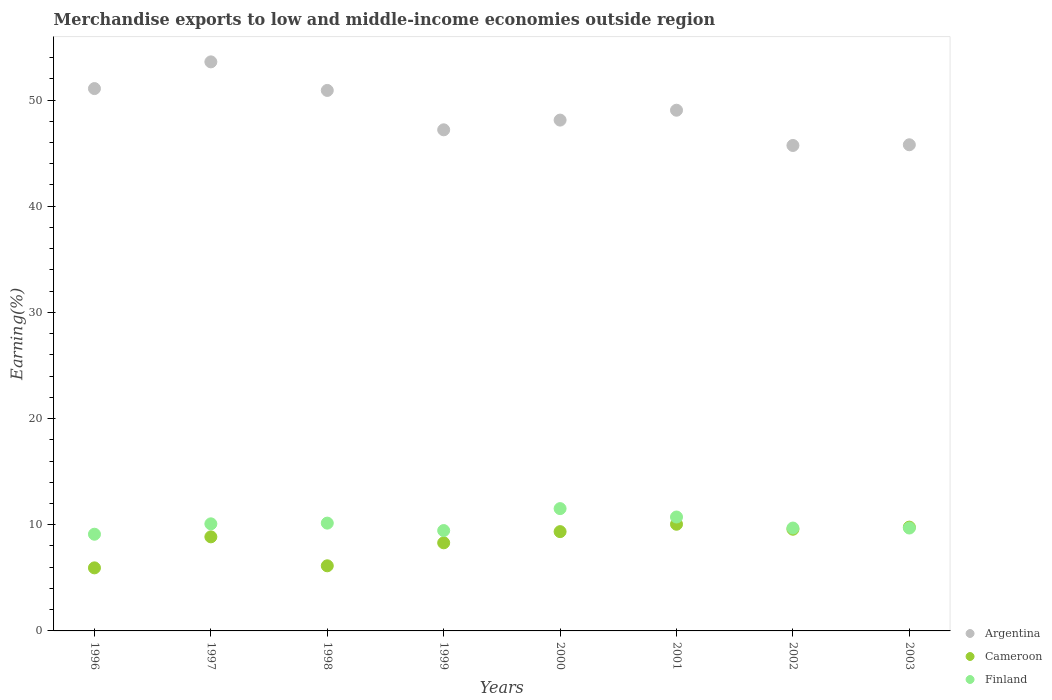How many different coloured dotlines are there?
Offer a terse response. 3. What is the percentage of amount earned from merchandise exports in Finland in 1996?
Your answer should be compact. 9.11. Across all years, what is the maximum percentage of amount earned from merchandise exports in Finland?
Make the answer very short. 11.52. Across all years, what is the minimum percentage of amount earned from merchandise exports in Argentina?
Your response must be concise. 45.72. What is the total percentage of amount earned from merchandise exports in Finland in the graph?
Your answer should be compact. 80.43. What is the difference between the percentage of amount earned from merchandise exports in Cameroon in 2000 and that in 2003?
Your answer should be very brief. -0.43. What is the difference between the percentage of amount earned from merchandise exports in Cameroon in 1997 and the percentage of amount earned from merchandise exports in Argentina in 1999?
Your answer should be very brief. -38.34. What is the average percentage of amount earned from merchandise exports in Finland per year?
Your answer should be very brief. 10.05. In the year 1996, what is the difference between the percentage of amount earned from merchandise exports in Finland and percentage of amount earned from merchandise exports in Cameroon?
Make the answer very short. 3.17. What is the ratio of the percentage of amount earned from merchandise exports in Argentina in 1996 to that in 2003?
Your response must be concise. 1.12. What is the difference between the highest and the second highest percentage of amount earned from merchandise exports in Cameroon?
Your answer should be compact. 0.27. What is the difference between the highest and the lowest percentage of amount earned from merchandise exports in Argentina?
Provide a short and direct response. 7.87. Does the percentage of amount earned from merchandise exports in Cameroon monotonically increase over the years?
Offer a terse response. No. How many years are there in the graph?
Ensure brevity in your answer.  8. Are the values on the major ticks of Y-axis written in scientific E-notation?
Your answer should be very brief. No. Does the graph contain any zero values?
Provide a short and direct response. No. Does the graph contain grids?
Your answer should be compact. No. How are the legend labels stacked?
Ensure brevity in your answer.  Vertical. What is the title of the graph?
Make the answer very short. Merchandise exports to low and middle-income economies outside region. What is the label or title of the X-axis?
Your answer should be very brief. Years. What is the label or title of the Y-axis?
Offer a very short reply. Earning(%). What is the Earning(%) in Argentina in 1996?
Provide a succinct answer. 51.08. What is the Earning(%) in Cameroon in 1996?
Keep it short and to the point. 5.94. What is the Earning(%) of Finland in 1996?
Make the answer very short. 9.11. What is the Earning(%) in Argentina in 1997?
Offer a very short reply. 53.6. What is the Earning(%) in Cameroon in 1997?
Offer a terse response. 8.86. What is the Earning(%) in Finland in 1997?
Offer a terse response. 10.09. What is the Earning(%) in Argentina in 1998?
Your answer should be compact. 50.91. What is the Earning(%) in Cameroon in 1998?
Provide a short and direct response. 6.13. What is the Earning(%) of Finland in 1998?
Provide a short and direct response. 10.15. What is the Earning(%) of Argentina in 1999?
Your answer should be very brief. 47.2. What is the Earning(%) of Cameroon in 1999?
Your response must be concise. 8.3. What is the Earning(%) of Finland in 1999?
Your answer should be very brief. 9.45. What is the Earning(%) in Argentina in 2000?
Offer a terse response. 48.11. What is the Earning(%) of Cameroon in 2000?
Provide a short and direct response. 9.35. What is the Earning(%) of Finland in 2000?
Provide a short and direct response. 11.52. What is the Earning(%) in Argentina in 2001?
Give a very brief answer. 49.04. What is the Earning(%) in Cameroon in 2001?
Provide a short and direct response. 10.05. What is the Earning(%) of Finland in 2001?
Keep it short and to the point. 10.73. What is the Earning(%) of Argentina in 2002?
Keep it short and to the point. 45.72. What is the Earning(%) of Cameroon in 2002?
Your answer should be compact. 9.58. What is the Earning(%) in Finland in 2002?
Give a very brief answer. 9.69. What is the Earning(%) in Argentina in 2003?
Give a very brief answer. 45.79. What is the Earning(%) of Cameroon in 2003?
Keep it short and to the point. 9.78. What is the Earning(%) of Finland in 2003?
Provide a short and direct response. 9.69. Across all years, what is the maximum Earning(%) of Argentina?
Keep it short and to the point. 53.6. Across all years, what is the maximum Earning(%) in Cameroon?
Provide a short and direct response. 10.05. Across all years, what is the maximum Earning(%) of Finland?
Provide a succinct answer. 11.52. Across all years, what is the minimum Earning(%) of Argentina?
Offer a very short reply. 45.72. Across all years, what is the minimum Earning(%) in Cameroon?
Ensure brevity in your answer.  5.94. Across all years, what is the minimum Earning(%) of Finland?
Keep it short and to the point. 9.11. What is the total Earning(%) in Argentina in the graph?
Ensure brevity in your answer.  391.44. What is the total Earning(%) of Cameroon in the graph?
Your response must be concise. 67.98. What is the total Earning(%) of Finland in the graph?
Offer a terse response. 80.43. What is the difference between the Earning(%) of Argentina in 1996 and that in 1997?
Your response must be concise. -2.51. What is the difference between the Earning(%) of Cameroon in 1996 and that in 1997?
Keep it short and to the point. -2.92. What is the difference between the Earning(%) in Finland in 1996 and that in 1997?
Keep it short and to the point. -0.98. What is the difference between the Earning(%) of Argentina in 1996 and that in 1998?
Your answer should be compact. 0.17. What is the difference between the Earning(%) in Cameroon in 1996 and that in 1998?
Offer a terse response. -0.19. What is the difference between the Earning(%) of Finland in 1996 and that in 1998?
Keep it short and to the point. -1.05. What is the difference between the Earning(%) in Argentina in 1996 and that in 1999?
Provide a succinct answer. 3.88. What is the difference between the Earning(%) in Cameroon in 1996 and that in 1999?
Keep it short and to the point. -2.36. What is the difference between the Earning(%) of Finland in 1996 and that in 1999?
Your response must be concise. -0.34. What is the difference between the Earning(%) in Argentina in 1996 and that in 2000?
Your answer should be compact. 2.97. What is the difference between the Earning(%) in Cameroon in 1996 and that in 2000?
Offer a very short reply. -3.41. What is the difference between the Earning(%) in Finland in 1996 and that in 2000?
Offer a terse response. -2.41. What is the difference between the Earning(%) in Argentina in 1996 and that in 2001?
Your answer should be very brief. 2.04. What is the difference between the Earning(%) in Cameroon in 1996 and that in 2001?
Your answer should be very brief. -4.11. What is the difference between the Earning(%) in Finland in 1996 and that in 2001?
Provide a succinct answer. -1.62. What is the difference between the Earning(%) of Argentina in 1996 and that in 2002?
Your answer should be very brief. 5.36. What is the difference between the Earning(%) in Cameroon in 1996 and that in 2002?
Offer a terse response. -3.64. What is the difference between the Earning(%) in Finland in 1996 and that in 2002?
Give a very brief answer. -0.58. What is the difference between the Earning(%) in Argentina in 1996 and that in 2003?
Give a very brief answer. 5.29. What is the difference between the Earning(%) of Cameroon in 1996 and that in 2003?
Offer a very short reply. -3.84. What is the difference between the Earning(%) in Finland in 1996 and that in 2003?
Your answer should be compact. -0.58. What is the difference between the Earning(%) in Argentina in 1997 and that in 1998?
Provide a succinct answer. 2.69. What is the difference between the Earning(%) in Cameroon in 1997 and that in 1998?
Your answer should be very brief. 2.73. What is the difference between the Earning(%) of Finland in 1997 and that in 1998?
Provide a succinct answer. -0.07. What is the difference between the Earning(%) of Argentina in 1997 and that in 1999?
Your answer should be compact. 6.4. What is the difference between the Earning(%) of Cameroon in 1997 and that in 1999?
Keep it short and to the point. 0.56. What is the difference between the Earning(%) in Finland in 1997 and that in 1999?
Provide a short and direct response. 0.63. What is the difference between the Earning(%) in Argentina in 1997 and that in 2000?
Your answer should be compact. 5.48. What is the difference between the Earning(%) of Cameroon in 1997 and that in 2000?
Provide a succinct answer. -0.49. What is the difference between the Earning(%) in Finland in 1997 and that in 2000?
Keep it short and to the point. -1.43. What is the difference between the Earning(%) in Argentina in 1997 and that in 2001?
Give a very brief answer. 4.55. What is the difference between the Earning(%) of Cameroon in 1997 and that in 2001?
Provide a short and direct response. -1.19. What is the difference between the Earning(%) in Finland in 1997 and that in 2001?
Your answer should be compact. -0.64. What is the difference between the Earning(%) in Argentina in 1997 and that in 2002?
Give a very brief answer. 7.87. What is the difference between the Earning(%) of Cameroon in 1997 and that in 2002?
Offer a terse response. -0.72. What is the difference between the Earning(%) of Finland in 1997 and that in 2002?
Provide a short and direct response. 0.4. What is the difference between the Earning(%) in Argentina in 1997 and that in 2003?
Offer a terse response. 7.81. What is the difference between the Earning(%) in Cameroon in 1997 and that in 2003?
Your response must be concise. -0.92. What is the difference between the Earning(%) in Finland in 1997 and that in 2003?
Make the answer very short. 0.39. What is the difference between the Earning(%) in Argentina in 1998 and that in 1999?
Ensure brevity in your answer.  3.71. What is the difference between the Earning(%) in Cameroon in 1998 and that in 1999?
Offer a terse response. -2.16. What is the difference between the Earning(%) in Finland in 1998 and that in 1999?
Ensure brevity in your answer.  0.7. What is the difference between the Earning(%) in Argentina in 1998 and that in 2000?
Provide a succinct answer. 2.79. What is the difference between the Earning(%) in Cameroon in 1998 and that in 2000?
Provide a short and direct response. -3.22. What is the difference between the Earning(%) in Finland in 1998 and that in 2000?
Ensure brevity in your answer.  -1.37. What is the difference between the Earning(%) of Argentina in 1998 and that in 2001?
Your answer should be compact. 1.86. What is the difference between the Earning(%) in Cameroon in 1998 and that in 2001?
Provide a short and direct response. -3.91. What is the difference between the Earning(%) of Finland in 1998 and that in 2001?
Make the answer very short. -0.58. What is the difference between the Earning(%) in Argentina in 1998 and that in 2002?
Offer a very short reply. 5.18. What is the difference between the Earning(%) in Cameroon in 1998 and that in 2002?
Offer a terse response. -3.44. What is the difference between the Earning(%) of Finland in 1998 and that in 2002?
Offer a very short reply. 0.46. What is the difference between the Earning(%) of Argentina in 1998 and that in 2003?
Give a very brief answer. 5.12. What is the difference between the Earning(%) in Cameroon in 1998 and that in 2003?
Offer a terse response. -3.64. What is the difference between the Earning(%) in Finland in 1998 and that in 2003?
Provide a short and direct response. 0.46. What is the difference between the Earning(%) of Argentina in 1999 and that in 2000?
Your response must be concise. -0.91. What is the difference between the Earning(%) in Cameroon in 1999 and that in 2000?
Your response must be concise. -1.05. What is the difference between the Earning(%) of Finland in 1999 and that in 2000?
Keep it short and to the point. -2.07. What is the difference between the Earning(%) in Argentina in 1999 and that in 2001?
Keep it short and to the point. -1.85. What is the difference between the Earning(%) in Cameroon in 1999 and that in 2001?
Give a very brief answer. -1.75. What is the difference between the Earning(%) in Finland in 1999 and that in 2001?
Provide a succinct answer. -1.28. What is the difference between the Earning(%) in Argentina in 1999 and that in 2002?
Make the answer very short. 1.47. What is the difference between the Earning(%) of Cameroon in 1999 and that in 2002?
Provide a succinct answer. -1.28. What is the difference between the Earning(%) in Finland in 1999 and that in 2002?
Provide a short and direct response. -0.24. What is the difference between the Earning(%) in Argentina in 1999 and that in 2003?
Ensure brevity in your answer.  1.41. What is the difference between the Earning(%) in Cameroon in 1999 and that in 2003?
Your answer should be compact. -1.48. What is the difference between the Earning(%) in Finland in 1999 and that in 2003?
Offer a very short reply. -0.24. What is the difference between the Earning(%) in Argentina in 2000 and that in 2001?
Make the answer very short. -0.93. What is the difference between the Earning(%) of Cameroon in 2000 and that in 2001?
Keep it short and to the point. -0.7. What is the difference between the Earning(%) in Finland in 2000 and that in 2001?
Make the answer very short. 0.79. What is the difference between the Earning(%) in Argentina in 2000 and that in 2002?
Offer a terse response. 2.39. What is the difference between the Earning(%) of Cameroon in 2000 and that in 2002?
Provide a succinct answer. -0.23. What is the difference between the Earning(%) of Finland in 2000 and that in 2002?
Ensure brevity in your answer.  1.83. What is the difference between the Earning(%) of Argentina in 2000 and that in 2003?
Your response must be concise. 2.32. What is the difference between the Earning(%) of Cameroon in 2000 and that in 2003?
Make the answer very short. -0.43. What is the difference between the Earning(%) in Finland in 2000 and that in 2003?
Offer a very short reply. 1.83. What is the difference between the Earning(%) in Argentina in 2001 and that in 2002?
Provide a succinct answer. 3.32. What is the difference between the Earning(%) in Cameroon in 2001 and that in 2002?
Offer a terse response. 0.47. What is the difference between the Earning(%) of Finland in 2001 and that in 2002?
Your answer should be compact. 1.04. What is the difference between the Earning(%) of Argentina in 2001 and that in 2003?
Ensure brevity in your answer.  3.25. What is the difference between the Earning(%) of Cameroon in 2001 and that in 2003?
Give a very brief answer. 0.27. What is the difference between the Earning(%) of Finland in 2001 and that in 2003?
Ensure brevity in your answer.  1.04. What is the difference between the Earning(%) of Argentina in 2002 and that in 2003?
Make the answer very short. -0.07. What is the difference between the Earning(%) in Cameroon in 2002 and that in 2003?
Give a very brief answer. -0.2. What is the difference between the Earning(%) in Finland in 2002 and that in 2003?
Make the answer very short. -0. What is the difference between the Earning(%) in Argentina in 1996 and the Earning(%) in Cameroon in 1997?
Keep it short and to the point. 42.22. What is the difference between the Earning(%) of Argentina in 1996 and the Earning(%) of Finland in 1997?
Give a very brief answer. 40.99. What is the difference between the Earning(%) of Cameroon in 1996 and the Earning(%) of Finland in 1997?
Your answer should be very brief. -4.15. What is the difference between the Earning(%) of Argentina in 1996 and the Earning(%) of Cameroon in 1998?
Offer a very short reply. 44.95. What is the difference between the Earning(%) in Argentina in 1996 and the Earning(%) in Finland in 1998?
Ensure brevity in your answer.  40.93. What is the difference between the Earning(%) of Cameroon in 1996 and the Earning(%) of Finland in 1998?
Offer a very short reply. -4.21. What is the difference between the Earning(%) of Argentina in 1996 and the Earning(%) of Cameroon in 1999?
Give a very brief answer. 42.78. What is the difference between the Earning(%) in Argentina in 1996 and the Earning(%) in Finland in 1999?
Ensure brevity in your answer.  41.63. What is the difference between the Earning(%) in Cameroon in 1996 and the Earning(%) in Finland in 1999?
Provide a succinct answer. -3.51. What is the difference between the Earning(%) of Argentina in 1996 and the Earning(%) of Cameroon in 2000?
Your answer should be compact. 41.73. What is the difference between the Earning(%) of Argentina in 1996 and the Earning(%) of Finland in 2000?
Provide a short and direct response. 39.56. What is the difference between the Earning(%) of Cameroon in 1996 and the Earning(%) of Finland in 2000?
Make the answer very short. -5.58. What is the difference between the Earning(%) in Argentina in 1996 and the Earning(%) in Cameroon in 2001?
Provide a succinct answer. 41.03. What is the difference between the Earning(%) in Argentina in 1996 and the Earning(%) in Finland in 2001?
Your answer should be very brief. 40.35. What is the difference between the Earning(%) of Cameroon in 1996 and the Earning(%) of Finland in 2001?
Your response must be concise. -4.79. What is the difference between the Earning(%) in Argentina in 1996 and the Earning(%) in Cameroon in 2002?
Your answer should be very brief. 41.5. What is the difference between the Earning(%) in Argentina in 1996 and the Earning(%) in Finland in 2002?
Make the answer very short. 41.39. What is the difference between the Earning(%) in Cameroon in 1996 and the Earning(%) in Finland in 2002?
Your answer should be very brief. -3.75. What is the difference between the Earning(%) in Argentina in 1996 and the Earning(%) in Cameroon in 2003?
Give a very brief answer. 41.3. What is the difference between the Earning(%) of Argentina in 1996 and the Earning(%) of Finland in 2003?
Ensure brevity in your answer.  41.39. What is the difference between the Earning(%) of Cameroon in 1996 and the Earning(%) of Finland in 2003?
Your answer should be compact. -3.75. What is the difference between the Earning(%) in Argentina in 1997 and the Earning(%) in Cameroon in 1998?
Offer a terse response. 47.46. What is the difference between the Earning(%) of Argentina in 1997 and the Earning(%) of Finland in 1998?
Keep it short and to the point. 43.44. What is the difference between the Earning(%) in Cameroon in 1997 and the Earning(%) in Finland in 1998?
Your response must be concise. -1.29. What is the difference between the Earning(%) in Argentina in 1997 and the Earning(%) in Cameroon in 1999?
Keep it short and to the point. 45.3. What is the difference between the Earning(%) in Argentina in 1997 and the Earning(%) in Finland in 1999?
Give a very brief answer. 44.14. What is the difference between the Earning(%) of Cameroon in 1997 and the Earning(%) of Finland in 1999?
Your response must be concise. -0.59. What is the difference between the Earning(%) of Argentina in 1997 and the Earning(%) of Cameroon in 2000?
Ensure brevity in your answer.  44.24. What is the difference between the Earning(%) of Argentina in 1997 and the Earning(%) of Finland in 2000?
Your response must be concise. 42.08. What is the difference between the Earning(%) of Cameroon in 1997 and the Earning(%) of Finland in 2000?
Provide a short and direct response. -2.66. What is the difference between the Earning(%) in Argentina in 1997 and the Earning(%) in Cameroon in 2001?
Provide a succinct answer. 43.55. What is the difference between the Earning(%) of Argentina in 1997 and the Earning(%) of Finland in 2001?
Give a very brief answer. 42.87. What is the difference between the Earning(%) of Cameroon in 1997 and the Earning(%) of Finland in 2001?
Provide a short and direct response. -1.87. What is the difference between the Earning(%) of Argentina in 1997 and the Earning(%) of Cameroon in 2002?
Your answer should be very brief. 44.02. What is the difference between the Earning(%) in Argentina in 1997 and the Earning(%) in Finland in 2002?
Offer a terse response. 43.91. What is the difference between the Earning(%) in Cameroon in 1997 and the Earning(%) in Finland in 2002?
Provide a succinct answer. -0.83. What is the difference between the Earning(%) of Argentina in 1997 and the Earning(%) of Cameroon in 2003?
Keep it short and to the point. 43.82. What is the difference between the Earning(%) of Argentina in 1997 and the Earning(%) of Finland in 2003?
Your answer should be very brief. 43.9. What is the difference between the Earning(%) of Cameroon in 1997 and the Earning(%) of Finland in 2003?
Make the answer very short. -0.83. What is the difference between the Earning(%) in Argentina in 1998 and the Earning(%) in Cameroon in 1999?
Your answer should be compact. 42.61. What is the difference between the Earning(%) in Argentina in 1998 and the Earning(%) in Finland in 1999?
Make the answer very short. 41.45. What is the difference between the Earning(%) of Cameroon in 1998 and the Earning(%) of Finland in 1999?
Offer a very short reply. -3.32. What is the difference between the Earning(%) in Argentina in 1998 and the Earning(%) in Cameroon in 2000?
Your response must be concise. 41.55. What is the difference between the Earning(%) in Argentina in 1998 and the Earning(%) in Finland in 2000?
Offer a terse response. 39.39. What is the difference between the Earning(%) of Cameroon in 1998 and the Earning(%) of Finland in 2000?
Your answer should be very brief. -5.39. What is the difference between the Earning(%) of Argentina in 1998 and the Earning(%) of Cameroon in 2001?
Provide a succinct answer. 40.86. What is the difference between the Earning(%) of Argentina in 1998 and the Earning(%) of Finland in 2001?
Offer a very short reply. 40.18. What is the difference between the Earning(%) in Cameroon in 1998 and the Earning(%) in Finland in 2001?
Offer a terse response. -4.6. What is the difference between the Earning(%) in Argentina in 1998 and the Earning(%) in Cameroon in 2002?
Your response must be concise. 41.33. What is the difference between the Earning(%) in Argentina in 1998 and the Earning(%) in Finland in 2002?
Your answer should be compact. 41.22. What is the difference between the Earning(%) of Cameroon in 1998 and the Earning(%) of Finland in 2002?
Offer a terse response. -3.56. What is the difference between the Earning(%) in Argentina in 1998 and the Earning(%) in Cameroon in 2003?
Offer a terse response. 41.13. What is the difference between the Earning(%) of Argentina in 1998 and the Earning(%) of Finland in 2003?
Your response must be concise. 41.21. What is the difference between the Earning(%) of Cameroon in 1998 and the Earning(%) of Finland in 2003?
Offer a terse response. -3.56. What is the difference between the Earning(%) in Argentina in 1999 and the Earning(%) in Cameroon in 2000?
Make the answer very short. 37.85. What is the difference between the Earning(%) in Argentina in 1999 and the Earning(%) in Finland in 2000?
Give a very brief answer. 35.68. What is the difference between the Earning(%) in Cameroon in 1999 and the Earning(%) in Finland in 2000?
Ensure brevity in your answer.  -3.22. What is the difference between the Earning(%) of Argentina in 1999 and the Earning(%) of Cameroon in 2001?
Offer a terse response. 37.15. What is the difference between the Earning(%) of Argentina in 1999 and the Earning(%) of Finland in 2001?
Make the answer very short. 36.47. What is the difference between the Earning(%) of Cameroon in 1999 and the Earning(%) of Finland in 2001?
Make the answer very short. -2.43. What is the difference between the Earning(%) in Argentina in 1999 and the Earning(%) in Cameroon in 2002?
Your answer should be very brief. 37.62. What is the difference between the Earning(%) in Argentina in 1999 and the Earning(%) in Finland in 2002?
Your answer should be very brief. 37.51. What is the difference between the Earning(%) in Cameroon in 1999 and the Earning(%) in Finland in 2002?
Offer a very short reply. -1.39. What is the difference between the Earning(%) of Argentina in 1999 and the Earning(%) of Cameroon in 2003?
Provide a succinct answer. 37.42. What is the difference between the Earning(%) of Argentina in 1999 and the Earning(%) of Finland in 2003?
Make the answer very short. 37.5. What is the difference between the Earning(%) of Cameroon in 1999 and the Earning(%) of Finland in 2003?
Your answer should be compact. -1.39. What is the difference between the Earning(%) in Argentina in 2000 and the Earning(%) in Cameroon in 2001?
Your answer should be compact. 38.06. What is the difference between the Earning(%) of Argentina in 2000 and the Earning(%) of Finland in 2001?
Provide a succinct answer. 37.38. What is the difference between the Earning(%) of Cameroon in 2000 and the Earning(%) of Finland in 2001?
Offer a terse response. -1.38. What is the difference between the Earning(%) of Argentina in 2000 and the Earning(%) of Cameroon in 2002?
Offer a terse response. 38.53. What is the difference between the Earning(%) in Argentina in 2000 and the Earning(%) in Finland in 2002?
Your response must be concise. 38.42. What is the difference between the Earning(%) in Cameroon in 2000 and the Earning(%) in Finland in 2002?
Your answer should be very brief. -0.34. What is the difference between the Earning(%) in Argentina in 2000 and the Earning(%) in Cameroon in 2003?
Provide a succinct answer. 38.34. What is the difference between the Earning(%) in Argentina in 2000 and the Earning(%) in Finland in 2003?
Your answer should be very brief. 38.42. What is the difference between the Earning(%) in Cameroon in 2000 and the Earning(%) in Finland in 2003?
Make the answer very short. -0.34. What is the difference between the Earning(%) of Argentina in 2001 and the Earning(%) of Cameroon in 2002?
Your response must be concise. 39.46. What is the difference between the Earning(%) in Argentina in 2001 and the Earning(%) in Finland in 2002?
Give a very brief answer. 39.35. What is the difference between the Earning(%) in Cameroon in 2001 and the Earning(%) in Finland in 2002?
Your answer should be compact. 0.36. What is the difference between the Earning(%) in Argentina in 2001 and the Earning(%) in Cameroon in 2003?
Give a very brief answer. 39.27. What is the difference between the Earning(%) of Argentina in 2001 and the Earning(%) of Finland in 2003?
Your answer should be compact. 39.35. What is the difference between the Earning(%) in Cameroon in 2001 and the Earning(%) in Finland in 2003?
Ensure brevity in your answer.  0.36. What is the difference between the Earning(%) of Argentina in 2002 and the Earning(%) of Cameroon in 2003?
Keep it short and to the point. 35.95. What is the difference between the Earning(%) of Argentina in 2002 and the Earning(%) of Finland in 2003?
Your answer should be very brief. 36.03. What is the difference between the Earning(%) in Cameroon in 2002 and the Earning(%) in Finland in 2003?
Your answer should be very brief. -0.11. What is the average Earning(%) in Argentina per year?
Offer a very short reply. 48.93. What is the average Earning(%) of Cameroon per year?
Make the answer very short. 8.5. What is the average Earning(%) of Finland per year?
Offer a very short reply. 10.05. In the year 1996, what is the difference between the Earning(%) of Argentina and Earning(%) of Cameroon?
Your answer should be very brief. 45.14. In the year 1996, what is the difference between the Earning(%) of Argentina and Earning(%) of Finland?
Keep it short and to the point. 41.97. In the year 1996, what is the difference between the Earning(%) of Cameroon and Earning(%) of Finland?
Keep it short and to the point. -3.17. In the year 1997, what is the difference between the Earning(%) of Argentina and Earning(%) of Cameroon?
Offer a very short reply. 44.73. In the year 1997, what is the difference between the Earning(%) in Argentina and Earning(%) in Finland?
Your answer should be compact. 43.51. In the year 1997, what is the difference between the Earning(%) in Cameroon and Earning(%) in Finland?
Ensure brevity in your answer.  -1.23. In the year 1998, what is the difference between the Earning(%) of Argentina and Earning(%) of Cameroon?
Your answer should be compact. 44.77. In the year 1998, what is the difference between the Earning(%) in Argentina and Earning(%) in Finland?
Your answer should be very brief. 40.75. In the year 1998, what is the difference between the Earning(%) of Cameroon and Earning(%) of Finland?
Offer a terse response. -4.02. In the year 1999, what is the difference between the Earning(%) in Argentina and Earning(%) in Cameroon?
Make the answer very short. 38.9. In the year 1999, what is the difference between the Earning(%) of Argentina and Earning(%) of Finland?
Make the answer very short. 37.75. In the year 1999, what is the difference between the Earning(%) of Cameroon and Earning(%) of Finland?
Ensure brevity in your answer.  -1.15. In the year 2000, what is the difference between the Earning(%) in Argentina and Earning(%) in Cameroon?
Your response must be concise. 38.76. In the year 2000, what is the difference between the Earning(%) in Argentina and Earning(%) in Finland?
Offer a very short reply. 36.59. In the year 2000, what is the difference between the Earning(%) in Cameroon and Earning(%) in Finland?
Your response must be concise. -2.17. In the year 2001, what is the difference between the Earning(%) in Argentina and Earning(%) in Cameroon?
Your response must be concise. 38.99. In the year 2001, what is the difference between the Earning(%) of Argentina and Earning(%) of Finland?
Make the answer very short. 38.31. In the year 2001, what is the difference between the Earning(%) in Cameroon and Earning(%) in Finland?
Your answer should be compact. -0.68. In the year 2002, what is the difference between the Earning(%) of Argentina and Earning(%) of Cameroon?
Your answer should be compact. 36.14. In the year 2002, what is the difference between the Earning(%) in Argentina and Earning(%) in Finland?
Your answer should be compact. 36.03. In the year 2002, what is the difference between the Earning(%) in Cameroon and Earning(%) in Finland?
Make the answer very short. -0.11. In the year 2003, what is the difference between the Earning(%) in Argentina and Earning(%) in Cameroon?
Give a very brief answer. 36.01. In the year 2003, what is the difference between the Earning(%) of Argentina and Earning(%) of Finland?
Give a very brief answer. 36.1. In the year 2003, what is the difference between the Earning(%) in Cameroon and Earning(%) in Finland?
Make the answer very short. 0.08. What is the ratio of the Earning(%) in Argentina in 1996 to that in 1997?
Offer a very short reply. 0.95. What is the ratio of the Earning(%) in Cameroon in 1996 to that in 1997?
Provide a succinct answer. 0.67. What is the ratio of the Earning(%) in Finland in 1996 to that in 1997?
Provide a short and direct response. 0.9. What is the ratio of the Earning(%) of Cameroon in 1996 to that in 1998?
Provide a short and direct response. 0.97. What is the ratio of the Earning(%) in Finland in 1996 to that in 1998?
Your answer should be compact. 0.9. What is the ratio of the Earning(%) of Argentina in 1996 to that in 1999?
Your response must be concise. 1.08. What is the ratio of the Earning(%) of Cameroon in 1996 to that in 1999?
Ensure brevity in your answer.  0.72. What is the ratio of the Earning(%) in Finland in 1996 to that in 1999?
Ensure brevity in your answer.  0.96. What is the ratio of the Earning(%) of Argentina in 1996 to that in 2000?
Your answer should be very brief. 1.06. What is the ratio of the Earning(%) of Cameroon in 1996 to that in 2000?
Your response must be concise. 0.64. What is the ratio of the Earning(%) in Finland in 1996 to that in 2000?
Ensure brevity in your answer.  0.79. What is the ratio of the Earning(%) in Argentina in 1996 to that in 2001?
Keep it short and to the point. 1.04. What is the ratio of the Earning(%) of Cameroon in 1996 to that in 2001?
Your answer should be very brief. 0.59. What is the ratio of the Earning(%) of Finland in 1996 to that in 2001?
Your answer should be compact. 0.85. What is the ratio of the Earning(%) in Argentina in 1996 to that in 2002?
Your response must be concise. 1.12. What is the ratio of the Earning(%) in Cameroon in 1996 to that in 2002?
Your answer should be very brief. 0.62. What is the ratio of the Earning(%) in Finland in 1996 to that in 2002?
Give a very brief answer. 0.94. What is the ratio of the Earning(%) of Argentina in 1996 to that in 2003?
Give a very brief answer. 1.12. What is the ratio of the Earning(%) in Cameroon in 1996 to that in 2003?
Make the answer very short. 0.61. What is the ratio of the Earning(%) in Finland in 1996 to that in 2003?
Make the answer very short. 0.94. What is the ratio of the Earning(%) in Argentina in 1997 to that in 1998?
Give a very brief answer. 1.05. What is the ratio of the Earning(%) in Cameroon in 1997 to that in 1998?
Provide a short and direct response. 1.44. What is the ratio of the Earning(%) in Argentina in 1997 to that in 1999?
Provide a succinct answer. 1.14. What is the ratio of the Earning(%) of Cameroon in 1997 to that in 1999?
Your answer should be compact. 1.07. What is the ratio of the Earning(%) in Finland in 1997 to that in 1999?
Provide a succinct answer. 1.07. What is the ratio of the Earning(%) of Argentina in 1997 to that in 2000?
Provide a short and direct response. 1.11. What is the ratio of the Earning(%) in Cameroon in 1997 to that in 2000?
Ensure brevity in your answer.  0.95. What is the ratio of the Earning(%) of Finland in 1997 to that in 2000?
Your answer should be very brief. 0.88. What is the ratio of the Earning(%) in Argentina in 1997 to that in 2001?
Offer a very short reply. 1.09. What is the ratio of the Earning(%) in Cameroon in 1997 to that in 2001?
Ensure brevity in your answer.  0.88. What is the ratio of the Earning(%) of Finland in 1997 to that in 2001?
Offer a very short reply. 0.94. What is the ratio of the Earning(%) of Argentina in 1997 to that in 2002?
Provide a short and direct response. 1.17. What is the ratio of the Earning(%) in Cameroon in 1997 to that in 2002?
Make the answer very short. 0.93. What is the ratio of the Earning(%) in Finland in 1997 to that in 2002?
Give a very brief answer. 1.04. What is the ratio of the Earning(%) of Argentina in 1997 to that in 2003?
Provide a short and direct response. 1.17. What is the ratio of the Earning(%) in Cameroon in 1997 to that in 2003?
Give a very brief answer. 0.91. What is the ratio of the Earning(%) in Finland in 1997 to that in 2003?
Offer a very short reply. 1.04. What is the ratio of the Earning(%) in Argentina in 1998 to that in 1999?
Ensure brevity in your answer.  1.08. What is the ratio of the Earning(%) in Cameroon in 1998 to that in 1999?
Offer a terse response. 0.74. What is the ratio of the Earning(%) in Finland in 1998 to that in 1999?
Provide a short and direct response. 1.07. What is the ratio of the Earning(%) of Argentina in 1998 to that in 2000?
Provide a succinct answer. 1.06. What is the ratio of the Earning(%) of Cameroon in 1998 to that in 2000?
Your answer should be compact. 0.66. What is the ratio of the Earning(%) of Finland in 1998 to that in 2000?
Offer a very short reply. 0.88. What is the ratio of the Earning(%) of Argentina in 1998 to that in 2001?
Offer a terse response. 1.04. What is the ratio of the Earning(%) in Cameroon in 1998 to that in 2001?
Give a very brief answer. 0.61. What is the ratio of the Earning(%) in Finland in 1998 to that in 2001?
Offer a very short reply. 0.95. What is the ratio of the Earning(%) in Argentina in 1998 to that in 2002?
Ensure brevity in your answer.  1.11. What is the ratio of the Earning(%) of Cameroon in 1998 to that in 2002?
Make the answer very short. 0.64. What is the ratio of the Earning(%) of Finland in 1998 to that in 2002?
Your answer should be compact. 1.05. What is the ratio of the Earning(%) of Argentina in 1998 to that in 2003?
Provide a short and direct response. 1.11. What is the ratio of the Earning(%) of Cameroon in 1998 to that in 2003?
Provide a short and direct response. 0.63. What is the ratio of the Earning(%) of Finland in 1998 to that in 2003?
Offer a terse response. 1.05. What is the ratio of the Earning(%) of Argentina in 1999 to that in 2000?
Keep it short and to the point. 0.98. What is the ratio of the Earning(%) in Cameroon in 1999 to that in 2000?
Offer a terse response. 0.89. What is the ratio of the Earning(%) of Finland in 1999 to that in 2000?
Keep it short and to the point. 0.82. What is the ratio of the Earning(%) in Argentina in 1999 to that in 2001?
Provide a succinct answer. 0.96. What is the ratio of the Earning(%) in Cameroon in 1999 to that in 2001?
Your response must be concise. 0.83. What is the ratio of the Earning(%) of Finland in 1999 to that in 2001?
Ensure brevity in your answer.  0.88. What is the ratio of the Earning(%) of Argentina in 1999 to that in 2002?
Your response must be concise. 1.03. What is the ratio of the Earning(%) of Cameroon in 1999 to that in 2002?
Make the answer very short. 0.87. What is the ratio of the Earning(%) in Finland in 1999 to that in 2002?
Keep it short and to the point. 0.98. What is the ratio of the Earning(%) of Argentina in 1999 to that in 2003?
Offer a terse response. 1.03. What is the ratio of the Earning(%) in Cameroon in 1999 to that in 2003?
Provide a succinct answer. 0.85. What is the ratio of the Earning(%) in Finland in 1999 to that in 2003?
Make the answer very short. 0.98. What is the ratio of the Earning(%) in Argentina in 2000 to that in 2001?
Ensure brevity in your answer.  0.98. What is the ratio of the Earning(%) of Cameroon in 2000 to that in 2001?
Provide a succinct answer. 0.93. What is the ratio of the Earning(%) in Finland in 2000 to that in 2001?
Keep it short and to the point. 1.07. What is the ratio of the Earning(%) in Argentina in 2000 to that in 2002?
Keep it short and to the point. 1.05. What is the ratio of the Earning(%) of Cameroon in 2000 to that in 2002?
Your answer should be compact. 0.98. What is the ratio of the Earning(%) of Finland in 2000 to that in 2002?
Keep it short and to the point. 1.19. What is the ratio of the Earning(%) in Argentina in 2000 to that in 2003?
Your answer should be compact. 1.05. What is the ratio of the Earning(%) in Cameroon in 2000 to that in 2003?
Provide a short and direct response. 0.96. What is the ratio of the Earning(%) of Finland in 2000 to that in 2003?
Your answer should be very brief. 1.19. What is the ratio of the Earning(%) in Argentina in 2001 to that in 2002?
Make the answer very short. 1.07. What is the ratio of the Earning(%) in Cameroon in 2001 to that in 2002?
Make the answer very short. 1.05. What is the ratio of the Earning(%) of Finland in 2001 to that in 2002?
Ensure brevity in your answer.  1.11. What is the ratio of the Earning(%) of Argentina in 2001 to that in 2003?
Give a very brief answer. 1.07. What is the ratio of the Earning(%) of Cameroon in 2001 to that in 2003?
Offer a very short reply. 1.03. What is the ratio of the Earning(%) of Finland in 2001 to that in 2003?
Give a very brief answer. 1.11. What is the ratio of the Earning(%) of Cameroon in 2002 to that in 2003?
Your response must be concise. 0.98. What is the difference between the highest and the second highest Earning(%) in Argentina?
Make the answer very short. 2.51. What is the difference between the highest and the second highest Earning(%) of Cameroon?
Ensure brevity in your answer.  0.27. What is the difference between the highest and the second highest Earning(%) of Finland?
Keep it short and to the point. 0.79. What is the difference between the highest and the lowest Earning(%) of Argentina?
Ensure brevity in your answer.  7.87. What is the difference between the highest and the lowest Earning(%) of Cameroon?
Make the answer very short. 4.11. What is the difference between the highest and the lowest Earning(%) of Finland?
Make the answer very short. 2.41. 